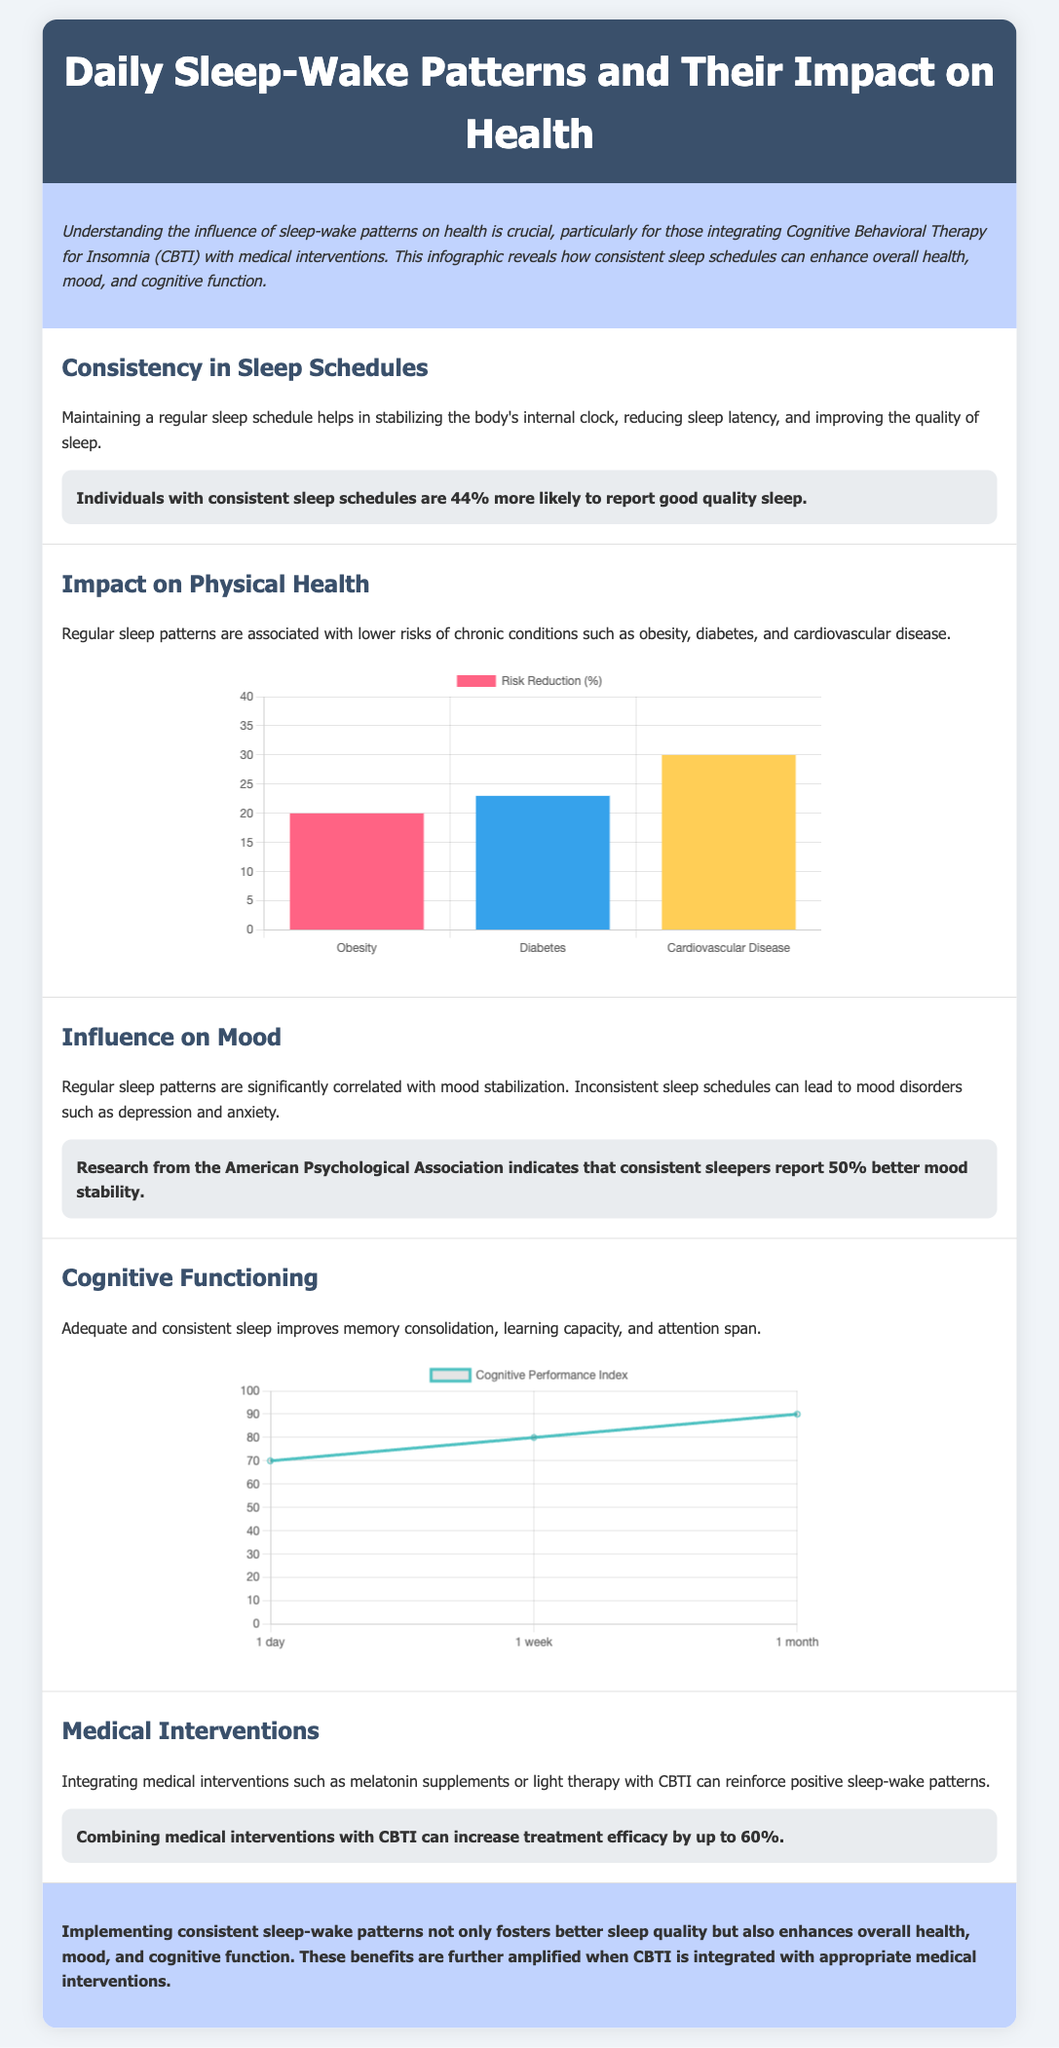what percentage more likely are individuals with consistent sleep schedules to report good quality sleep? The document states that individuals with consistent sleep schedules are 44% more likely to report good quality sleep.
Answer: 44% what is the risk reduction percentage for cardiovascular disease with regular sleep patterns? The chart indicates that the risk reduction for cardiovascular disease is 30%.
Answer: 30% how much more effective can combining medical interventions with CBTI be? The document states that combining medical interventions with CBTI can increase treatment efficacy by up to 60%.
Answer: 60% what does research indicate about mood stability for consistent sleepers? According to the document, consistent sleepers report 50% better mood stability.
Answer: 50% in which section is the impact on physical health discussed? The section that discusses the impact on physical health is titled "Impact on Physical Health".
Answer: Impact on Physical Health what is the trend of the Cognitive Performance Index over a month according to the chart? The chart shows an increasing trend in the Cognitive Performance Index from 70 to 90 over a month.
Answer: Increasing how many chronic conditions are listed as being associated with irregular sleep patterns? The document primarily mentions three chronic conditions: obesity, diabetes, and cardiovascular disease.
Answer: Three what is the main focus of the introductory paragraph? The introductory paragraph focuses on understanding the influence of sleep-wake patterns on health, particularly in the context of integrating CBTI with medical interventions.
Answer: Influence of sleep-wake patterns on health what is the color of the bar representing diabetes in the health impact chart? The color of the bar representing diabetes in the chart is blue.
Answer: Blue 